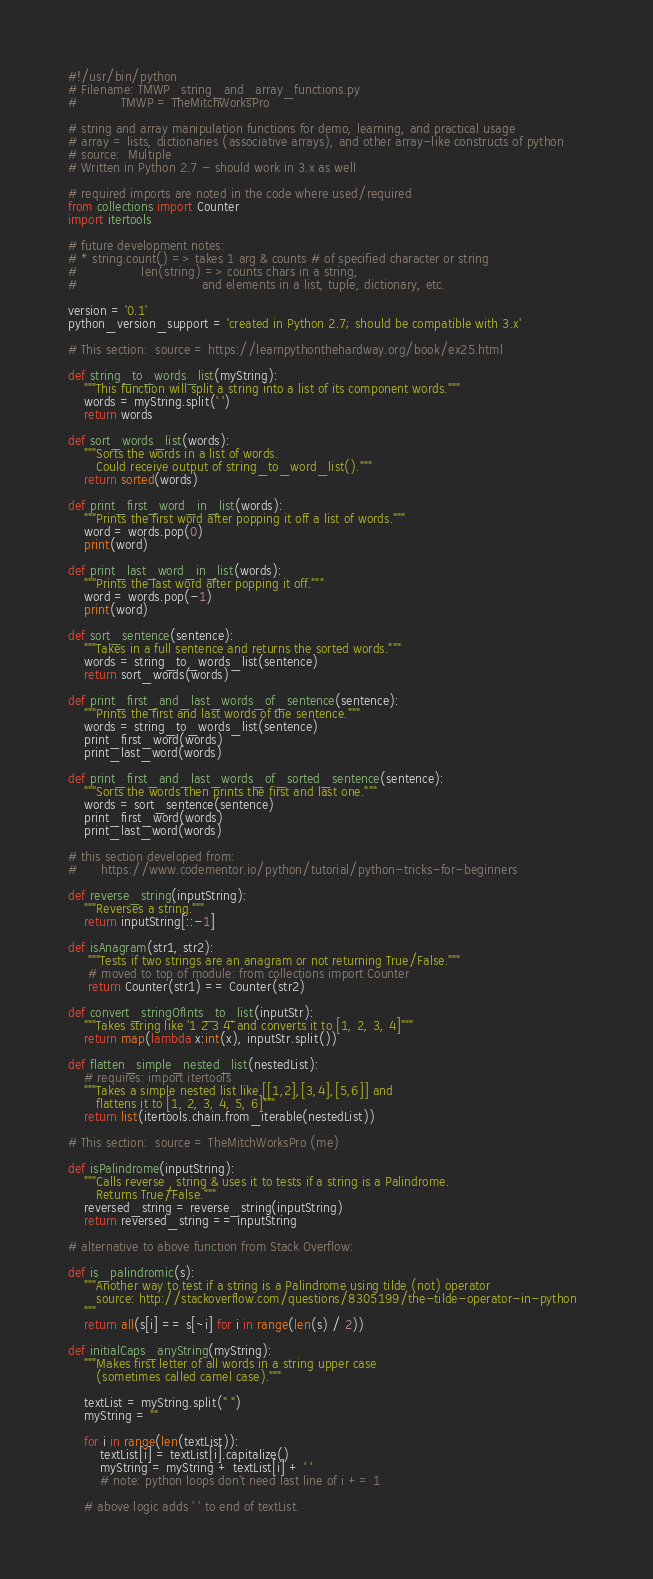<code> <loc_0><loc_0><loc_500><loc_500><_Python_>#!/usr/bin/python
# Filename: TMWP_string_and_array_functions.py
#           TMWP = TheMitchWorksPro

# string and array manipulation functions for demo, learning, and practical usage
# array = lists, dictionaries (associative arrays), and other array-like constructs of python
# source:  Multiple
# Written in Python 2.7 - should work in 3.x as well

# required imports are noted in the code where used/required
from collections import Counter
import itertools

# future development notes:
# * string.count() => takes 1 arg & counts # of specified character or string
#                len(string) => counts chars in a string, 
#                               and elements in a list, tuple, dictionary, etc.

version = '0.1'
python_version_support = 'created in Python 2.7; should be compatible with 3.x'

# This section:  source = https://learnpythonthehardway.org/book/ex25.html

def string_to_words_list(myString):
    """This function will split a string into a list of its component words."""
    words = myString.split(' ')
    return words

def sort_words_list(words):
    """Sorts the words in a list of words.  
	   Could receive output of string_to_word_list()."""
    return sorted(words)

def print_first_word_in_list(words):
    """Prints the first word after popping it off a list of words."""
    word = words.pop(0)
    print(word)

def print_last_word_in_list(words):
    """Prints the last word after popping it off."""
    word = words.pop(-1)
    print(word)

def sort_sentence(sentence):
    """Takes in a full sentence and returns the sorted words."""
    words = string_to_words_list(sentence)
    return sort_words(words)

def print_first_and_last_words_of_sentence(sentence):
    """Prints the first and last words of the sentence."""
    words = string_to_words_list(sentence)
    print_first_word(words)
    print_last_word(words)

def print_first_and_last_words_of_sorted_sentence(sentence):
    """Sorts the words then prints the first and last one."""
    words = sort_sentence(sentence)
    print_first_word(words)
    print_last_word(words)

# this section developed from: 
#      https://www.codementor.io/python/tutorial/python-tricks-for-beginners

def reverse_string(inputString):
    """Reverses a string."""
    return inputString[::-1]

def isAnagram(str1, str2):
     """Tests if two strings are an anagram or not returning True/False."""
     # moved to top of module: from collections import Counter
     return Counter(str1) == Counter(str2)

def convert_stringOfInts_to_list(inputStr):
    """Takes string like '1 2 3 4' and converts it to [1, 2, 3, 4]"""
    return map(lambda x:int(x), inputStr.split())

def flatten_simple_nested_list(nestedList):
    # requires: import itertools
    """Takes a simple nested list like [[1,2],[3,4],[5,6]] and 
	   flattens it to [1, 2, 3, 4, 5, 6]"""
    return list(itertools.chain.from_iterable(nestedList))	 
	 
# This section:  source = TheMitchWorksPro (me)

def isPalindrome(inputString):
    """Calls reverse_string & uses it to tests if a string is a Palindrome.  
	   Returns True/False."""
    reversed_string = reverse_string(inputString)
    return reversed_string == inputString

# alternative to above function from Stack Overflow:

def is_palindromic(s):
    """Another way to test if a string is a Palindrome using tilde (not) operator 
	   source: http://stackoverflow.com/questions/8305199/the-tilde-operator-in-python  
	"""
    return all(s[i] == s[~i] for i in range(len(s) / 2))
	
def initialCaps_anyString(myString):
    """Makes first letter of all words in a string upper case 
	   (sometimes called camel case)."""
    
    textList = myString.split(" ")
    myString = ""
    
    for i in range(len(textList)):
        textList[i] = textList[i].capitalize()
        myString = myString + textList[i] + ' '
		# note: python loops don't need last line of i += 1
    
    # above logic adds ' ' to end of textList.  </code> 